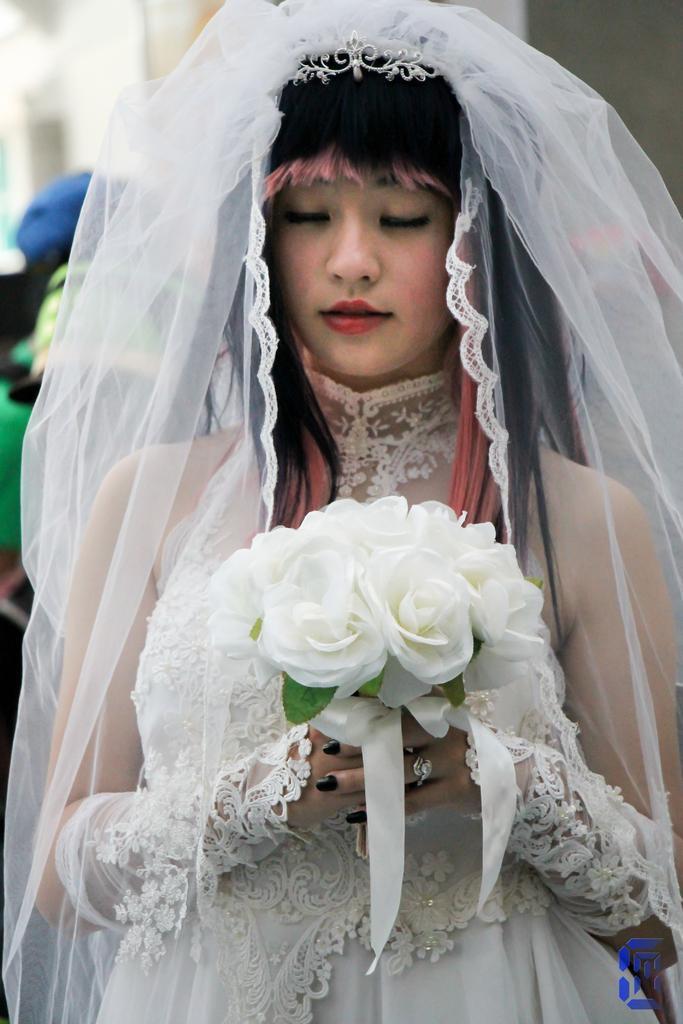Please provide a concise description of this image. In this picture I can see a woman standing and holding flowers in her hands and she is wearing a cloth on her head and I can see another human and a building in the back. 